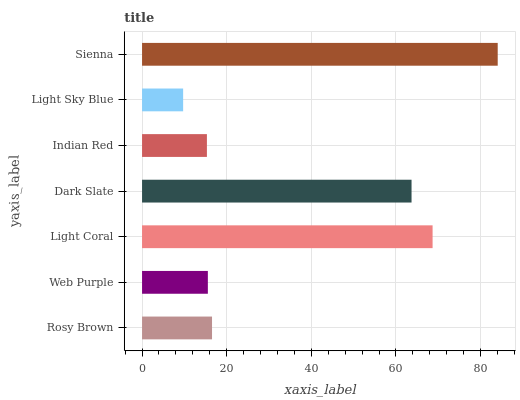Is Light Sky Blue the minimum?
Answer yes or no. Yes. Is Sienna the maximum?
Answer yes or no. Yes. Is Web Purple the minimum?
Answer yes or no. No. Is Web Purple the maximum?
Answer yes or no. No. Is Rosy Brown greater than Web Purple?
Answer yes or no. Yes. Is Web Purple less than Rosy Brown?
Answer yes or no. Yes. Is Web Purple greater than Rosy Brown?
Answer yes or no. No. Is Rosy Brown less than Web Purple?
Answer yes or no. No. Is Rosy Brown the high median?
Answer yes or no. Yes. Is Rosy Brown the low median?
Answer yes or no. Yes. Is Light Coral the high median?
Answer yes or no. No. Is Light Coral the low median?
Answer yes or no. No. 